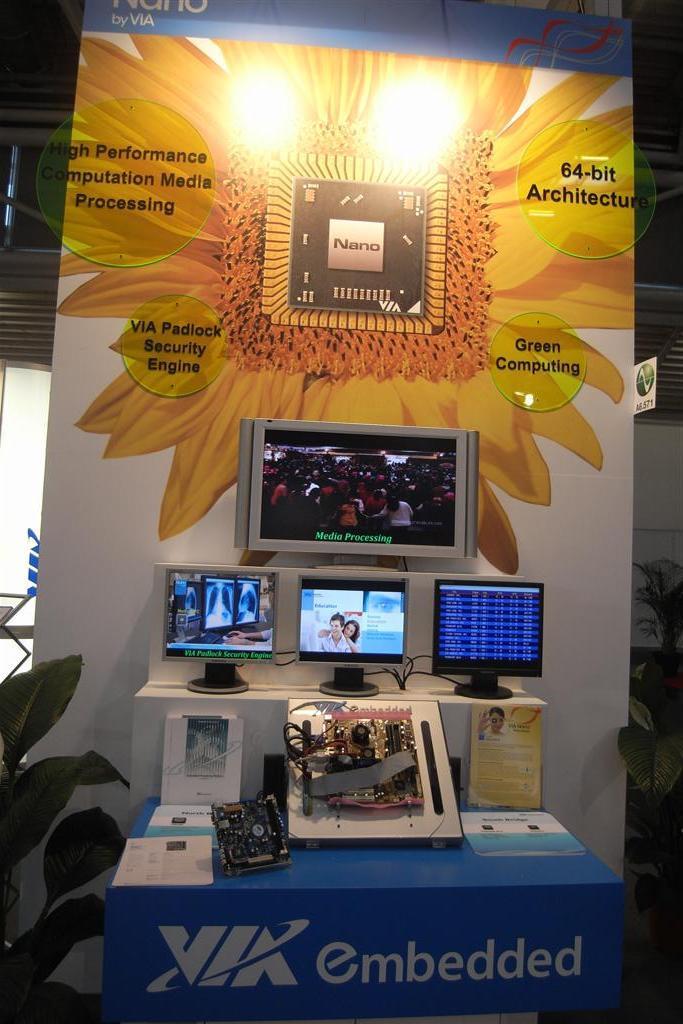Is via concerned about the environment?
Keep it short and to the point. Yes. What is the blue word on the bottom?
Make the answer very short. Embedded. 